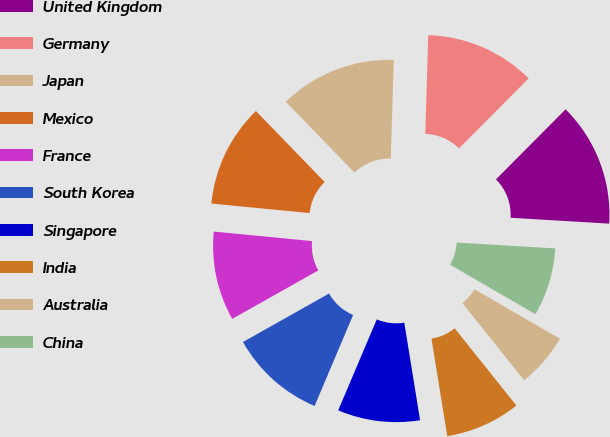Convert chart. <chart><loc_0><loc_0><loc_500><loc_500><pie_chart><fcel>United Kingdom<fcel>Germany<fcel>Japan<fcel>Mexico<fcel>France<fcel>South Korea<fcel>Singapore<fcel>India<fcel>Australia<fcel>China<nl><fcel>13.49%<fcel>11.98%<fcel>12.73%<fcel>11.22%<fcel>9.7%<fcel>10.46%<fcel>8.94%<fcel>8.18%<fcel>5.9%<fcel>7.42%<nl></chart> 